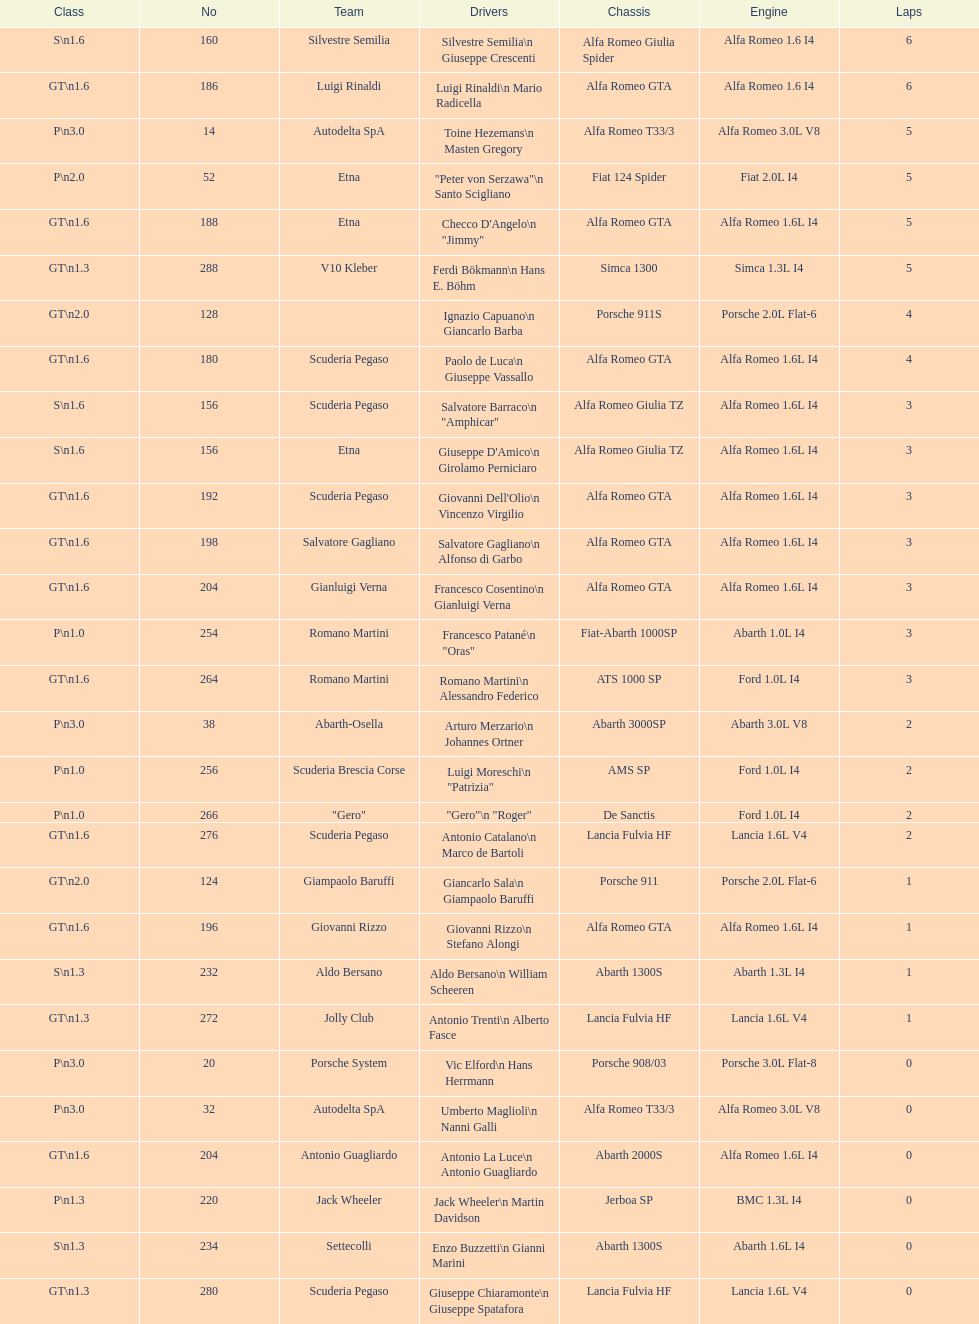6? GT 1.6. 